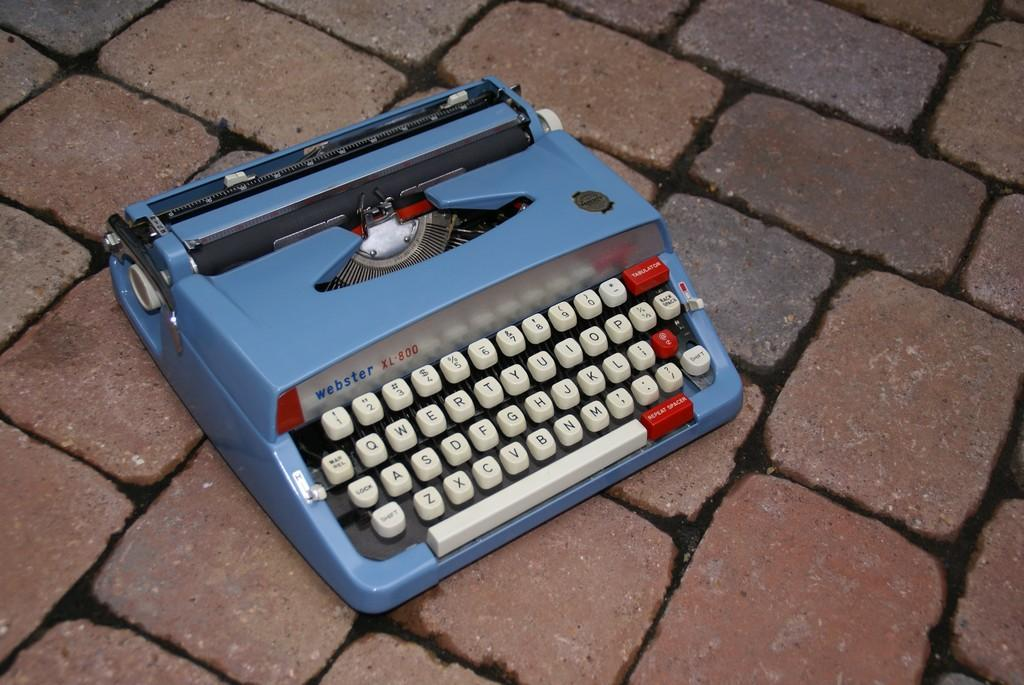Provide a one-sentence caption for the provided image. Blue webster xl 800 typewriter on top of some bricks. 